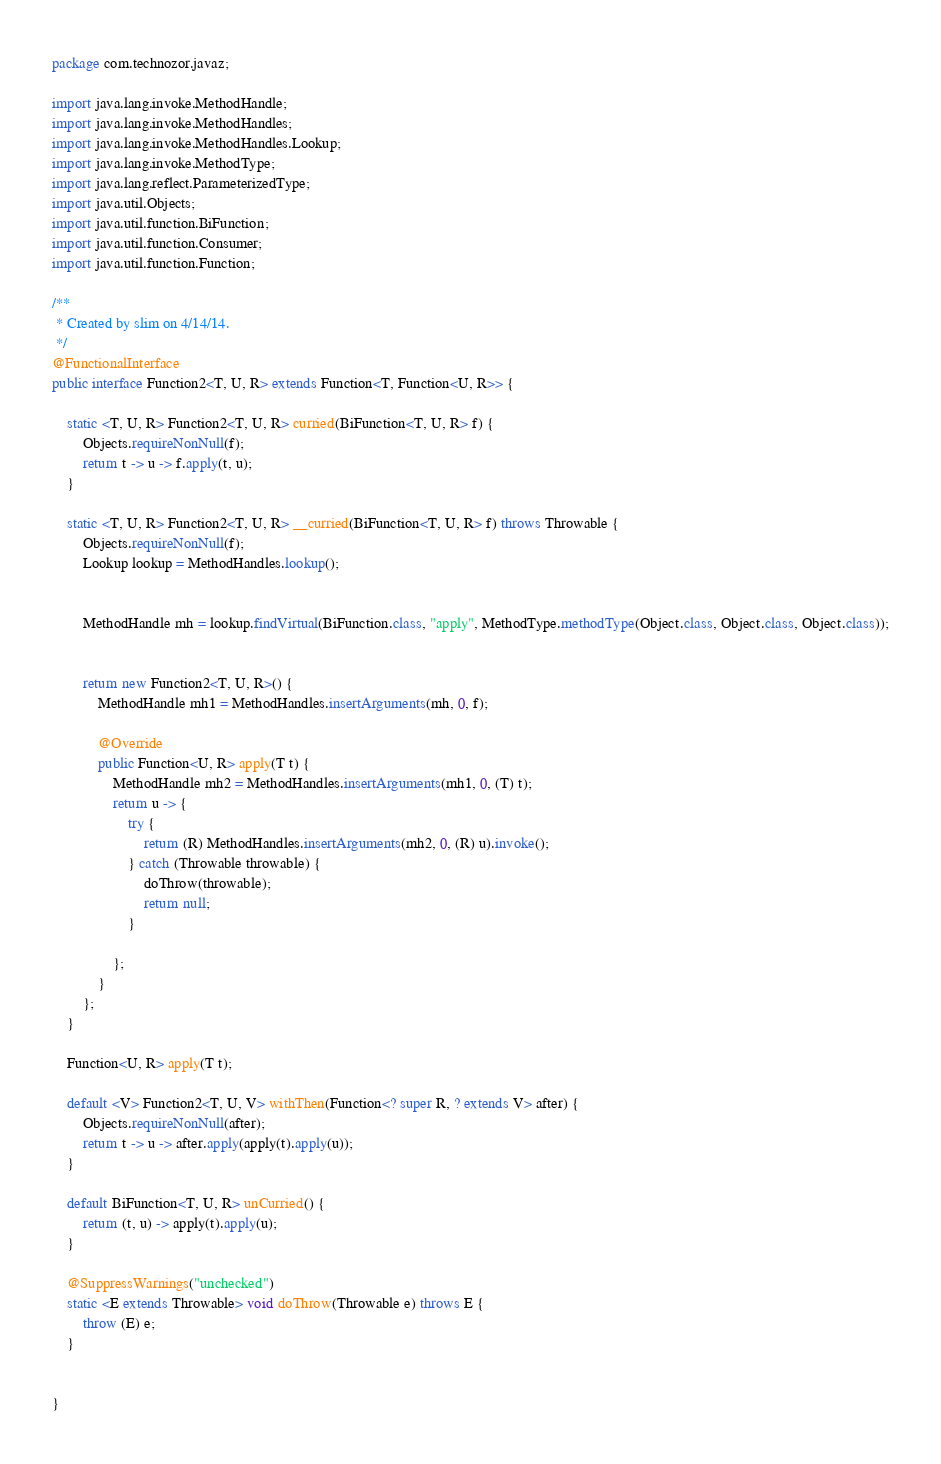<code> <loc_0><loc_0><loc_500><loc_500><_Java_>package com.technozor.javaz;

import java.lang.invoke.MethodHandle;
import java.lang.invoke.MethodHandles;
import java.lang.invoke.MethodHandles.Lookup;
import java.lang.invoke.MethodType;
import java.lang.reflect.ParameterizedType;
import java.util.Objects;
import java.util.function.BiFunction;
import java.util.function.Consumer;
import java.util.function.Function;

/**
 * Created by slim on 4/14/14.
 */
@FunctionalInterface
public interface Function2<T, U, R> extends Function<T, Function<U, R>> {

    static <T, U, R> Function2<T, U, R> curried(BiFunction<T, U, R> f) {
        Objects.requireNonNull(f);
        return t -> u -> f.apply(t, u);
    }

    static <T, U, R> Function2<T, U, R> __curried(BiFunction<T, U, R> f) throws Throwable {
        Objects.requireNonNull(f);
        Lookup lookup = MethodHandles.lookup();


        MethodHandle mh = lookup.findVirtual(BiFunction.class, "apply", MethodType.methodType(Object.class, Object.class, Object.class));


        return new Function2<T, U, R>() {
            MethodHandle mh1 = MethodHandles.insertArguments(mh, 0, f);

            @Override
            public Function<U, R> apply(T t) {
                MethodHandle mh2 = MethodHandles.insertArguments(mh1, 0, (T) t);
                return u -> {
                    try {
                        return (R) MethodHandles.insertArguments(mh2, 0, (R) u).invoke();
                    } catch (Throwable throwable) {
                        doThrow(throwable);
                        return null;
                    }

                };
            }
        };
    }

    Function<U, R> apply(T t);

    default <V> Function2<T, U, V> withThen(Function<? super R, ? extends V> after) {
        Objects.requireNonNull(after);
        return t -> u -> after.apply(apply(t).apply(u));
    }

    default BiFunction<T, U, R> unCurried() {
        return (t, u) -> apply(t).apply(u);
    }

    @SuppressWarnings("unchecked")
    static <E extends Throwable> void doThrow(Throwable e) throws E {
        throw (E) e;
    }


}
</code> 